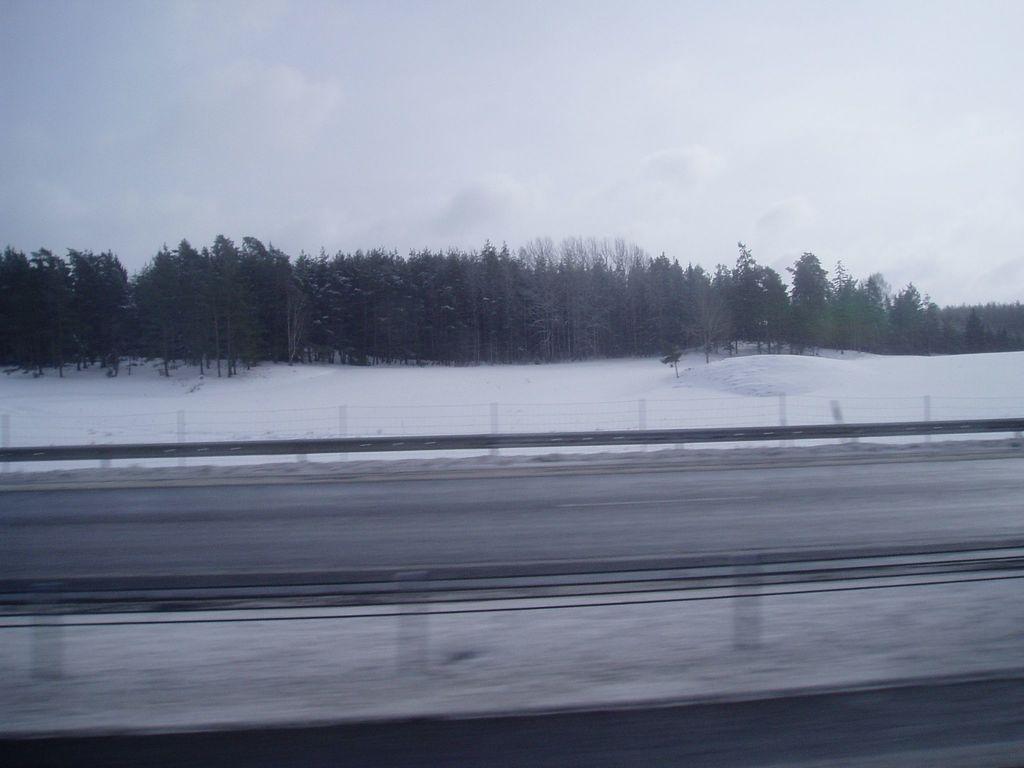In one or two sentences, can you explain what this image depicts? In this picture there is a road and there is a fence beside it and the ground is covered with snow beside the fence and there are trees in the background. 